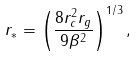Convert formula to latex. <formula><loc_0><loc_0><loc_500><loc_500>r _ { * } = \left ( \frac { 8 r _ { c } ^ { 2 } r _ { g } } { 9 \beta ^ { 2 } } \right ) ^ { 1 / 3 } ,</formula> 